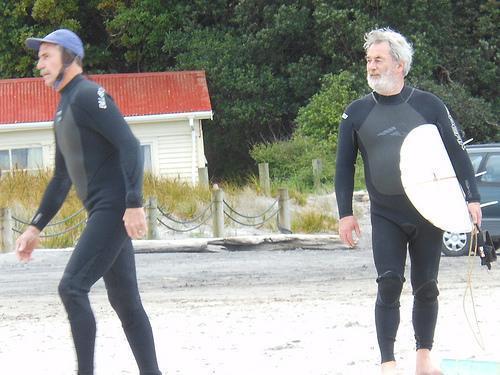How many men?
Give a very brief answer. 2. How many people are there?
Give a very brief answer. 2. 